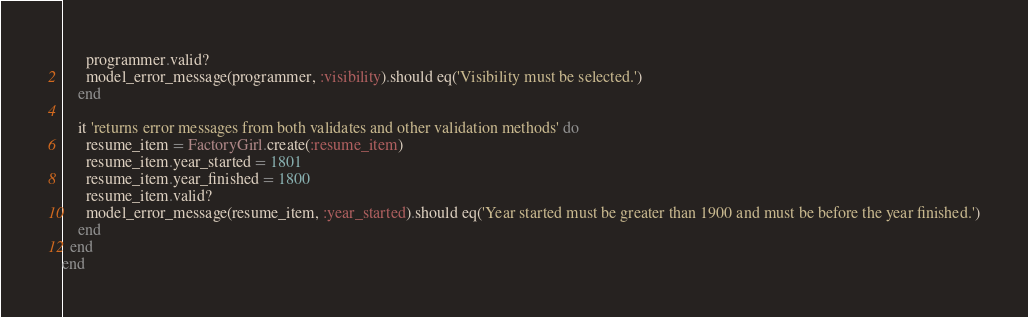Convert code to text. <code><loc_0><loc_0><loc_500><loc_500><_Ruby_>      programmer.valid?
      model_error_message(programmer, :visibility).should eq('Visibility must be selected.')
    end

    it 'returns error messages from both validates and other validation methods' do
      resume_item = FactoryGirl.create(:resume_item)
      resume_item.year_started = 1801
      resume_item.year_finished = 1800
      resume_item.valid?
      model_error_message(resume_item, :year_started).should eq('Year started must be greater than 1900 and must be before the year finished.')
    end
  end
end
</code> 